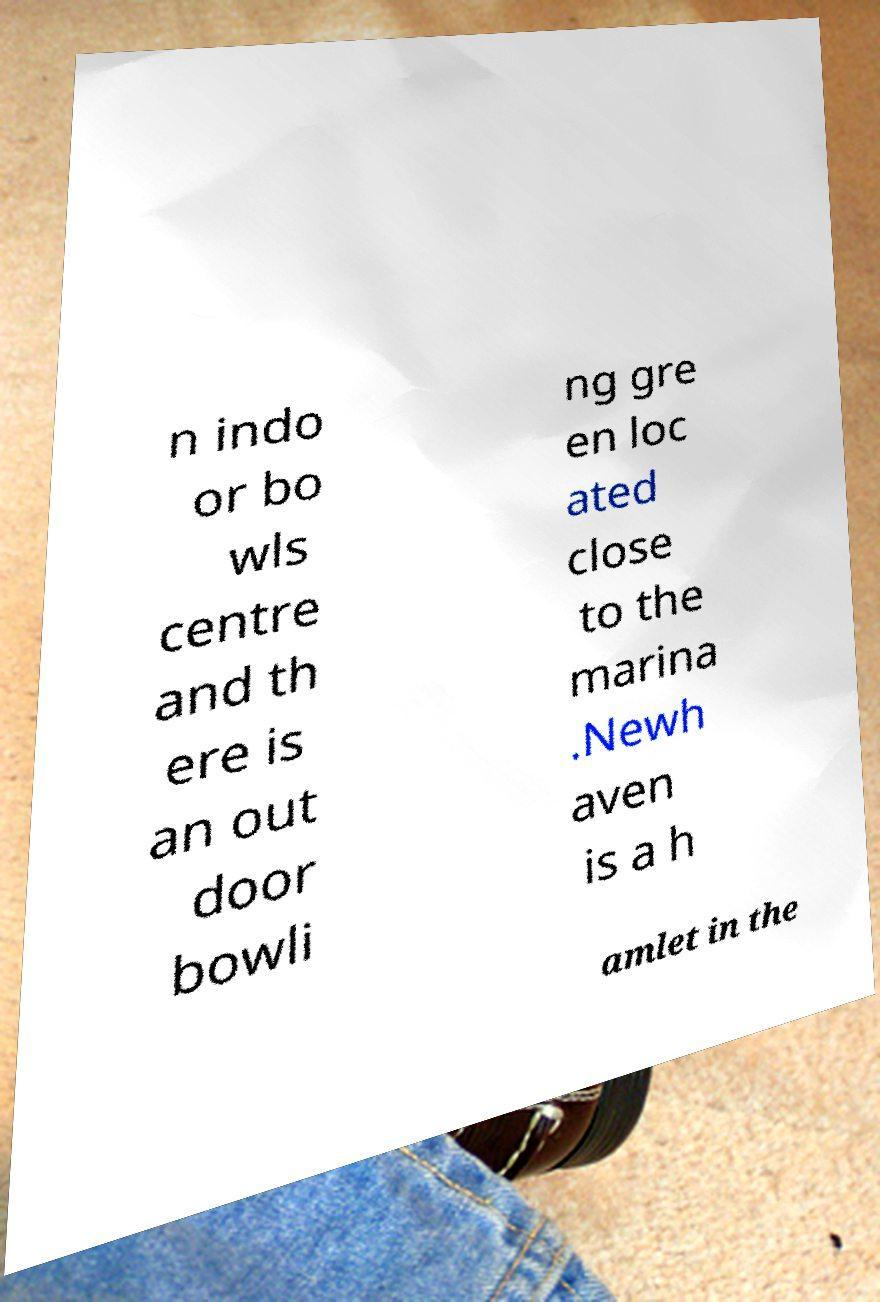Please identify and transcribe the text found in this image. n indo or bo wls centre and th ere is an out door bowli ng gre en loc ated close to the marina .Newh aven is a h amlet in the 